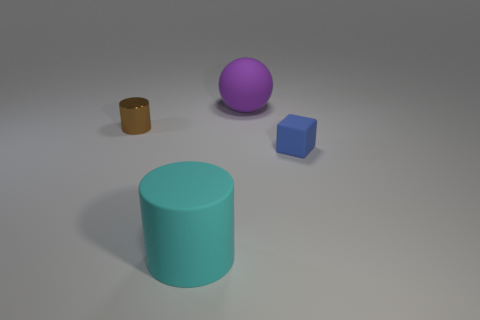Is there another rubber object that has the same size as the blue matte thing?
Your response must be concise. No. Is the number of rubber cylinders less than the number of small green metallic spheres?
Provide a succinct answer. No. There is a object that is to the right of the big matte thing behind the cylinder behind the block; what shape is it?
Ensure brevity in your answer.  Cube. How many things are big objects that are on the right side of the cyan thing or cylinders that are on the left side of the large rubber cylinder?
Make the answer very short. 2. There is a small brown object; are there any tiny things on the left side of it?
Your answer should be compact. No. What number of objects are tiny objects on the right side of the metallic thing or tiny brown objects?
Ensure brevity in your answer.  2. What number of blue objects are either small blocks or small things?
Ensure brevity in your answer.  1. Is the number of tiny metal things that are on the right side of the small blue rubber object less than the number of brown cylinders?
Your answer should be compact. Yes. There is a large object on the left side of the large thing behind the thing that is left of the cyan cylinder; what color is it?
Ensure brevity in your answer.  Cyan. Is there anything else that has the same material as the brown thing?
Offer a very short reply. No. 